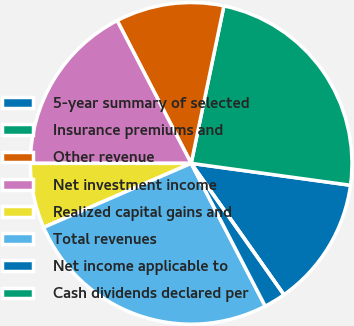Convert chart to OTSL. <chart><loc_0><loc_0><loc_500><loc_500><pie_chart><fcel>5-year summary of selected<fcel>Insurance premiums and<fcel>Other revenue<fcel>Net investment income<fcel>Realized capital gains and<fcel>Total revenues<fcel>Net income applicable to<fcel>Cash dividends declared per<nl><fcel>13.04%<fcel>23.91%<fcel>10.87%<fcel>17.39%<fcel>6.52%<fcel>26.09%<fcel>2.17%<fcel>0.0%<nl></chart> 